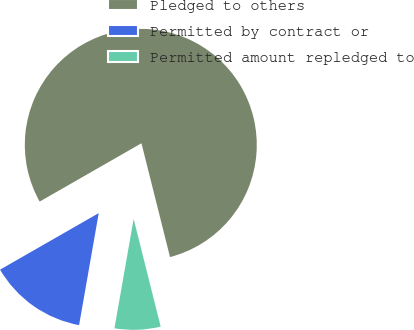Convert chart to OTSL. <chart><loc_0><loc_0><loc_500><loc_500><pie_chart><fcel>Pledged to others<fcel>Permitted by contract or<fcel>Permitted amount repledged to<nl><fcel>79.37%<fcel>13.95%<fcel>6.68%<nl></chart> 